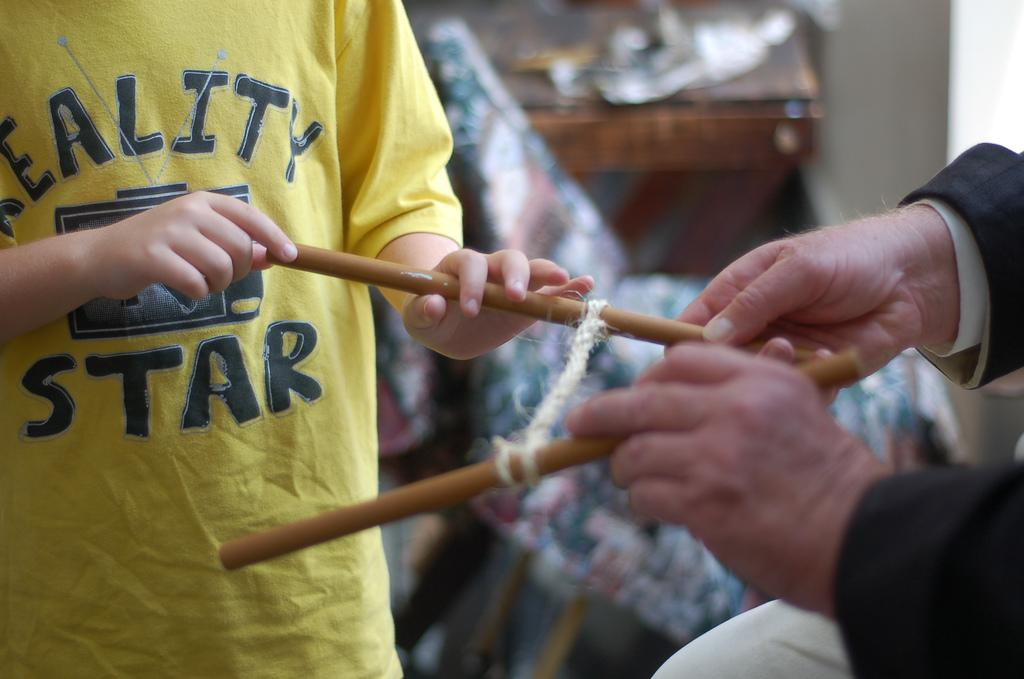<image>
Relay a brief, clear account of the picture shown. Person wearing a yellow shirt that says reality star holding a yarn stick. 